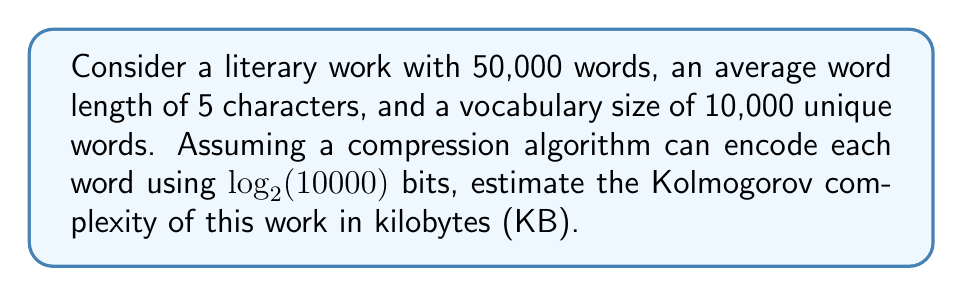Could you help me with this problem? To estimate the Kolmogorov complexity of the literary work, we'll follow these steps:

1. Calculate the number of bits needed to encode each word:
   $\log_2(10000) \approx 13.29$ bits

2. Calculate the total number of bits for all words:
   $50000 \times 13.29 = 664500$ bits

3. Convert bits to bytes:
   $664500 \div 8 = 83062.5$ bytes

4. Convert bytes to kilobytes:
   $83062.5 \div 1024 \approx 81.12$ KB

5. Round to the nearest whole number:
   $81$ KB

This estimate assumes that the compression algorithm can efficiently encode the structure and patterns in the text. The actual Kolmogorov complexity might be lower if there are additional regularities in the text that can be compressed further.

It's worth noting that this is a simplified estimation. In practice, the Kolmogorov complexity is often approximated using various compression algorithms, as finding the true Kolmogorov complexity is generally undecidable.
Answer: 81 KB 